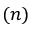Convert formula to latex. <formula><loc_0><loc_0><loc_500><loc_500>( n )</formula> 